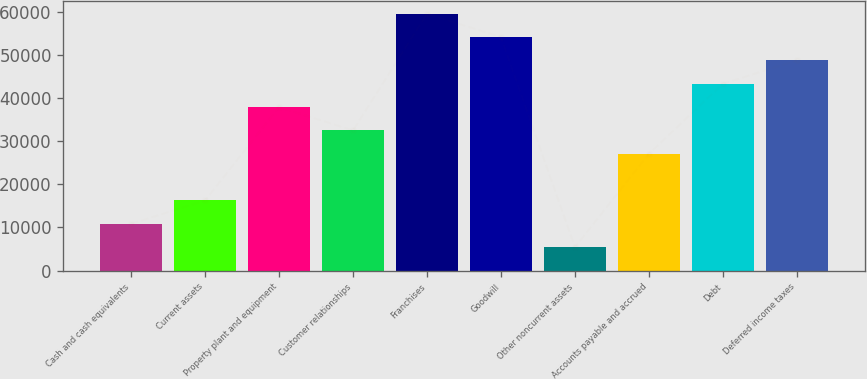<chart> <loc_0><loc_0><loc_500><loc_500><bar_chart><fcel>Cash and cash equivalents<fcel>Current assets<fcel>Property plant and equipment<fcel>Customer relationships<fcel>Franchises<fcel>Goodwill<fcel>Other noncurrent assets<fcel>Accounts payable and accrued<fcel>Debt<fcel>Deferred income taxes<nl><fcel>10820.2<fcel>16228.3<fcel>37860.7<fcel>32452.6<fcel>59493.1<fcel>54085<fcel>5412.1<fcel>27044.5<fcel>43268.8<fcel>48676.9<nl></chart> 